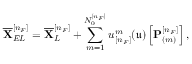<formula> <loc_0><loc_0><loc_500><loc_500>\overline { X } _ { E L } ^ { [ n _ { F } ] } = \overline { X } _ { L } ^ { [ n _ { F } ] } + \sum _ { m = 1 } ^ { N _ { 0 } ^ { [ n _ { F } ] } } u _ { [ n _ { F } ] } ^ { m } ( \mathfrak { u } ) \left [ P _ { ( m ) } ^ { [ n _ { F } ] } \right ] ,</formula> 